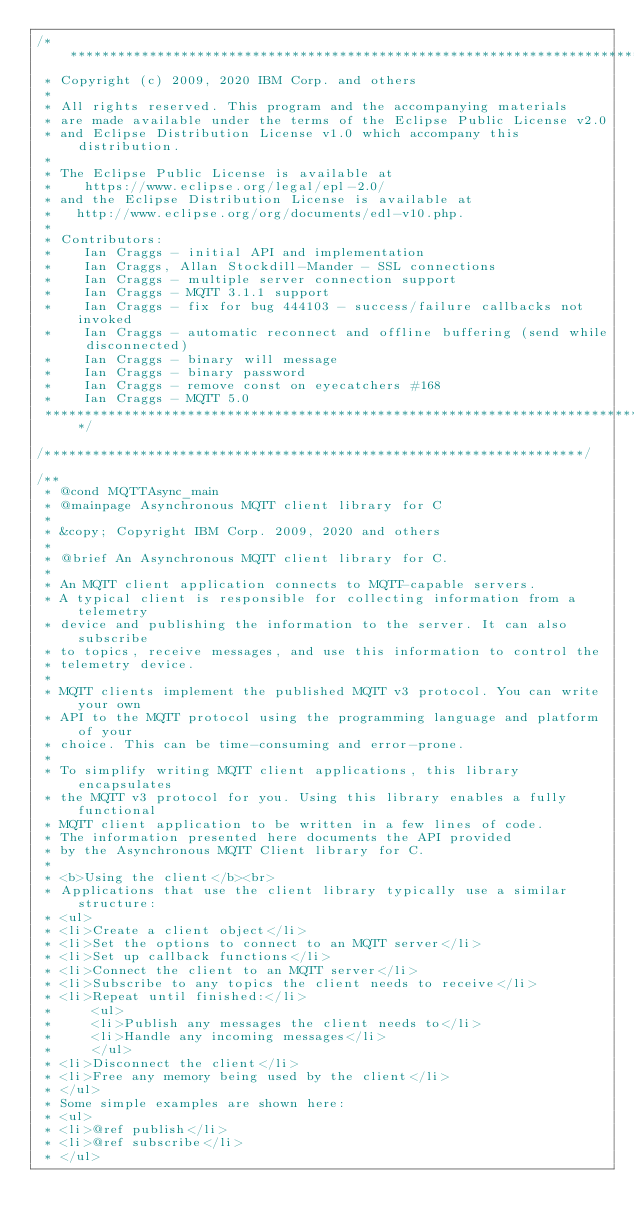<code> <loc_0><loc_0><loc_500><loc_500><_C_>/*******************************************************************************
 * Copyright (c) 2009, 2020 IBM Corp. and others
 *
 * All rights reserved. This program and the accompanying materials
 * are made available under the terms of the Eclipse Public License v2.0
 * and Eclipse Distribution License v1.0 which accompany this distribution.
 *
 * The Eclipse Public License is available at
 *    https://www.eclipse.org/legal/epl-2.0/
 * and the Eclipse Distribution License is available at
 *   http://www.eclipse.org/org/documents/edl-v10.php.
 *
 * Contributors:
 *    Ian Craggs - initial API and implementation
 *    Ian Craggs, Allan Stockdill-Mander - SSL connections
 *    Ian Craggs - multiple server connection support
 *    Ian Craggs - MQTT 3.1.1 support
 *    Ian Craggs - fix for bug 444103 - success/failure callbacks not invoked
 *    Ian Craggs - automatic reconnect and offline buffering (send while disconnected)
 *    Ian Craggs - binary will message
 *    Ian Craggs - binary password
 *    Ian Craggs - remove const on eyecatchers #168
 *    Ian Craggs - MQTT 5.0
 *******************************************************************************/

/********************************************************************/

/**
 * @cond MQTTAsync_main
 * @mainpage Asynchronous MQTT client library for C
 *
 * &copy; Copyright IBM Corp. 2009, 2020 and others
 *
 * @brief An Asynchronous MQTT client library for C.
 *
 * An MQTT client application connects to MQTT-capable servers.
 * A typical client is responsible for collecting information from a telemetry
 * device and publishing the information to the server. It can also subscribe
 * to topics, receive messages, and use this information to control the
 * telemetry device.
 *
 * MQTT clients implement the published MQTT v3 protocol. You can write your own
 * API to the MQTT protocol using the programming language and platform of your
 * choice. This can be time-consuming and error-prone.
 *
 * To simplify writing MQTT client applications, this library encapsulates
 * the MQTT v3 protocol for you. Using this library enables a fully functional
 * MQTT client application to be written in a few lines of code.
 * The information presented here documents the API provided
 * by the Asynchronous MQTT Client library for C.
 *
 * <b>Using the client</b><br>
 * Applications that use the client library typically use a similar structure:
 * <ul>
 * <li>Create a client object</li>
 * <li>Set the options to connect to an MQTT server</li>
 * <li>Set up callback functions</li>
 * <li>Connect the client to an MQTT server</li>
 * <li>Subscribe to any topics the client needs to receive</li>
 * <li>Repeat until finished:</li>
 *     <ul>
 *     <li>Publish any messages the client needs to</li>
 *     <li>Handle any incoming messages</li>
 *     </ul>
 * <li>Disconnect the client</li>
 * <li>Free any memory being used by the client</li>
 * </ul>
 * Some simple examples are shown here:
 * <ul>
 * <li>@ref publish</li>
 * <li>@ref subscribe</li>
 * </ul></code> 